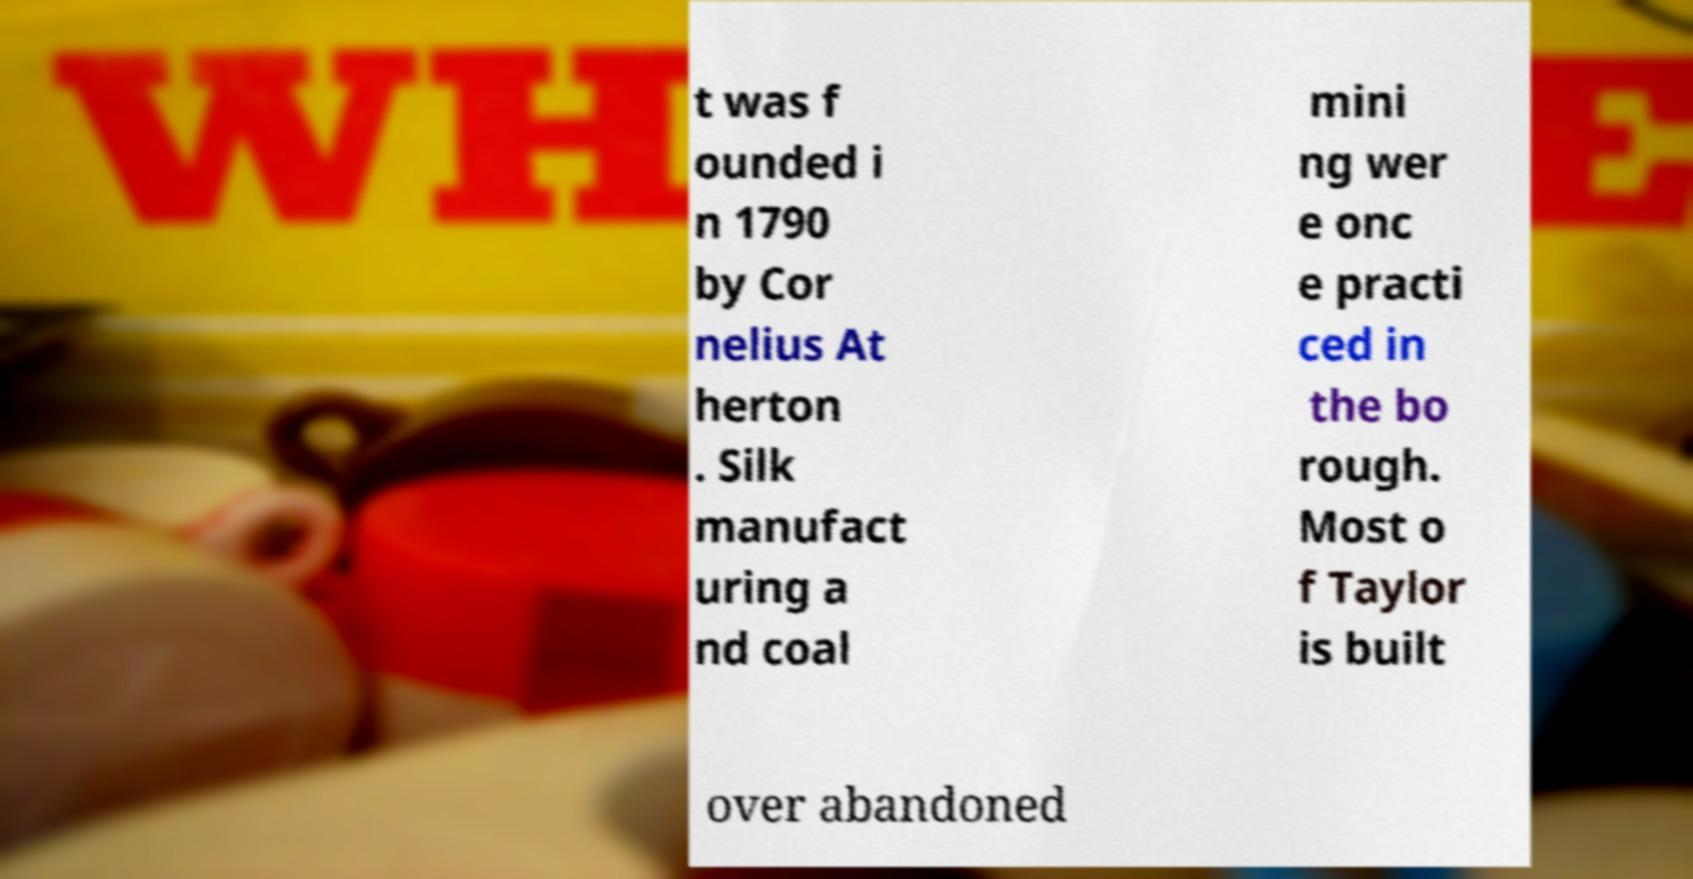For documentation purposes, I need the text within this image transcribed. Could you provide that? t was f ounded i n 1790 by Cor nelius At herton . Silk manufact uring a nd coal mini ng wer e onc e practi ced in the bo rough. Most o f Taylor is built over abandoned 